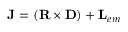<formula> <loc_0><loc_0><loc_500><loc_500>{ J } = ( { R \times D } ) + { L } _ { e m }</formula> 